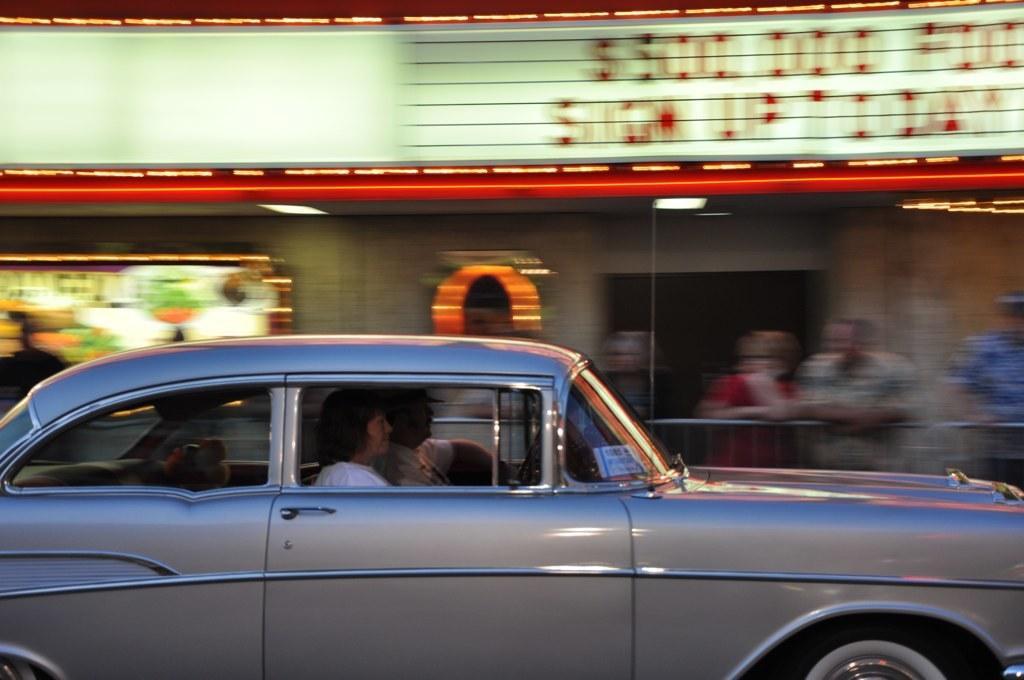Describe this image in one or two sentences. This picture is of outside. In the foreground we can see a car and a woman and a man sitting in the car. The background is Blurry and in the background we can see a shop and some persons standing. 